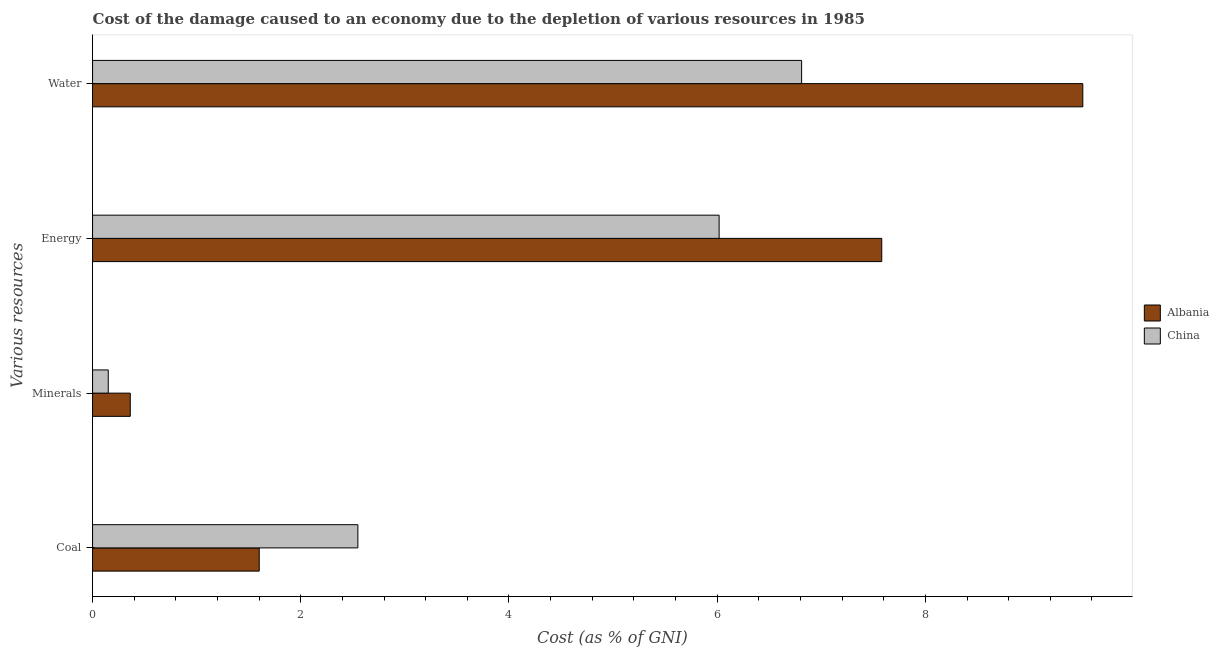How many different coloured bars are there?
Offer a terse response. 2. Are the number of bars per tick equal to the number of legend labels?
Your answer should be very brief. Yes. How many bars are there on the 4th tick from the top?
Keep it short and to the point. 2. What is the label of the 3rd group of bars from the top?
Provide a succinct answer. Minerals. What is the cost of damage due to depletion of coal in China?
Keep it short and to the point. 2.55. Across all countries, what is the maximum cost of damage due to depletion of minerals?
Your answer should be compact. 0.36. Across all countries, what is the minimum cost of damage due to depletion of coal?
Give a very brief answer. 1.6. In which country was the cost of damage due to depletion of coal minimum?
Your response must be concise. Albania. What is the total cost of damage due to depletion of coal in the graph?
Give a very brief answer. 4.15. What is the difference between the cost of damage due to depletion of water in China and that in Albania?
Ensure brevity in your answer.  -2.7. What is the difference between the cost of damage due to depletion of coal in China and the cost of damage due to depletion of minerals in Albania?
Provide a succinct answer. 2.19. What is the average cost of damage due to depletion of coal per country?
Offer a very short reply. 2.07. What is the difference between the cost of damage due to depletion of coal and cost of damage due to depletion of energy in Albania?
Keep it short and to the point. -5.98. What is the ratio of the cost of damage due to depletion of coal in Albania to that in China?
Your answer should be compact. 0.63. Is the cost of damage due to depletion of energy in China less than that in Albania?
Offer a very short reply. Yes. Is the difference between the cost of damage due to depletion of water in China and Albania greater than the difference between the cost of damage due to depletion of coal in China and Albania?
Your response must be concise. No. What is the difference between the highest and the second highest cost of damage due to depletion of water?
Offer a very short reply. 2.7. What is the difference between the highest and the lowest cost of damage due to depletion of energy?
Ensure brevity in your answer.  1.56. Is the sum of the cost of damage due to depletion of coal in Albania and China greater than the maximum cost of damage due to depletion of minerals across all countries?
Make the answer very short. Yes. What does the 2nd bar from the top in Minerals represents?
Your response must be concise. Albania. Is it the case that in every country, the sum of the cost of damage due to depletion of coal and cost of damage due to depletion of minerals is greater than the cost of damage due to depletion of energy?
Provide a succinct answer. No. What is the difference between two consecutive major ticks on the X-axis?
Provide a short and direct response. 2. Are the values on the major ticks of X-axis written in scientific E-notation?
Ensure brevity in your answer.  No. How are the legend labels stacked?
Your answer should be compact. Vertical. What is the title of the graph?
Your answer should be very brief. Cost of the damage caused to an economy due to the depletion of various resources in 1985 . Does "Monaco" appear as one of the legend labels in the graph?
Offer a very short reply. No. What is the label or title of the X-axis?
Offer a terse response. Cost (as % of GNI). What is the label or title of the Y-axis?
Keep it short and to the point. Various resources. What is the Cost (as % of GNI) in Albania in Coal?
Give a very brief answer. 1.6. What is the Cost (as % of GNI) of China in Coal?
Provide a short and direct response. 2.55. What is the Cost (as % of GNI) of Albania in Minerals?
Your answer should be very brief. 0.36. What is the Cost (as % of GNI) of China in Minerals?
Make the answer very short. 0.15. What is the Cost (as % of GNI) in Albania in Energy?
Your response must be concise. 7.58. What is the Cost (as % of GNI) of China in Energy?
Make the answer very short. 6.02. What is the Cost (as % of GNI) in Albania in Water?
Offer a terse response. 9.51. What is the Cost (as % of GNI) in China in Water?
Offer a terse response. 6.81. Across all Various resources, what is the maximum Cost (as % of GNI) of Albania?
Your answer should be compact. 9.51. Across all Various resources, what is the maximum Cost (as % of GNI) in China?
Your answer should be compact. 6.81. Across all Various resources, what is the minimum Cost (as % of GNI) in Albania?
Make the answer very short. 0.36. Across all Various resources, what is the minimum Cost (as % of GNI) in China?
Make the answer very short. 0.15. What is the total Cost (as % of GNI) of Albania in the graph?
Provide a short and direct response. 19.06. What is the total Cost (as % of GNI) in China in the graph?
Ensure brevity in your answer.  15.53. What is the difference between the Cost (as % of GNI) in Albania in Coal and that in Minerals?
Your response must be concise. 1.24. What is the difference between the Cost (as % of GNI) in China in Coal and that in Minerals?
Provide a succinct answer. 2.4. What is the difference between the Cost (as % of GNI) in Albania in Coal and that in Energy?
Your answer should be compact. -5.98. What is the difference between the Cost (as % of GNI) of China in Coal and that in Energy?
Offer a very short reply. -3.47. What is the difference between the Cost (as % of GNI) in Albania in Coal and that in Water?
Offer a terse response. -7.91. What is the difference between the Cost (as % of GNI) in China in Coal and that in Water?
Your response must be concise. -4.26. What is the difference between the Cost (as % of GNI) of Albania in Minerals and that in Energy?
Your answer should be very brief. -7.22. What is the difference between the Cost (as % of GNI) in China in Minerals and that in Energy?
Your answer should be compact. -5.87. What is the difference between the Cost (as % of GNI) of Albania in Minerals and that in Water?
Keep it short and to the point. -9.15. What is the difference between the Cost (as % of GNI) of China in Minerals and that in Water?
Your answer should be very brief. -6.66. What is the difference between the Cost (as % of GNI) of Albania in Energy and that in Water?
Give a very brief answer. -1.93. What is the difference between the Cost (as % of GNI) of China in Energy and that in Water?
Provide a short and direct response. -0.79. What is the difference between the Cost (as % of GNI) in Albania in Coal and the Cost (as % of GNI) in China in Minerals?
Make the answer very short. 1.45. What is the difference between the Cost (as % of GNI) of Albania in Coal and the Cost (as % of GNI) of China in Energy?
Your response must be concise. -4.42. What is the difference between the Cost (as % of GNI) in Albania in Coal and the Cost (as % of GNI) in China in Water?
Your answer should be very brief. -5.21. What is the difference between the Cost (as % of GNI) of Albania in Minerals and the Cost (as % of GNI) of China in Energy?
Ensure brevity in your answer.  -5.66. What is the difference between the Cost (as % of GNI) of Albania in Minerals and the Cost (as % of GNI) of China in Water?
Offer a terse response. -6.45. What is the difference between the Cost (as % of GNI) of Albania in Energy and the Cost (as % of GNI) of China in Water?
Provide a short and direct response. 0.77. What is the average Cost (as % of GNI) of Albania per Various resources?
Make the answer very short. 4.76. What is the average Cost (as % of GNI) of China per Various resources?
Your response must be concise. 3.88. What is the difference between the Cost (as % of GNI) of Albania and Cost (as % of GNI) of China in Coal?
Your answer should be very brief. -0.95. What is the difference between the Cost (as % of GNI) in Albania and Cost (as % of GNI) in China in Minerals?
Provide a short and direct response. 0.21. What is the difference between the Cost (as % of GNI) in Albania and Cost (as % of GNI) in China in Energy?
Offer a very short reply. 1.56. What is the difference between the Cost (as % of GNI) in Albania and Cost (as % of GNI) in China in Water?
Make the answer very short. 2.7. What is the ratio of the Cost (as % of GNI) of Albania in Coal to that in Minerals?
Give a very brief answer. 4.42. What is the ratio of the Cost (as % of GNI) in China in Coal to that in Minerals?
Keep it short and to the point. 16.91. What is the ratio of the Cost (as % of GNI) of Albania in Coal to that in Energy?
Give a very brief answer. 0.21. What is the ratio of the Cost (as % of GNI) of China in Coal to that in Energy?
Keep it short and to the point. 0.42. What is the ratio of the Cost (as % of GNI) of Albania in Coal to that in Water?
Ensure brevity in your answer.  0.17. What is the ratio of the Cost (as % of GNI) in China in Coal to that in Water?
Give a very brief answer. 0.37. What is the ratio of the Cost (as % of GNI) in Albania in Minerals to that in Energy?
Keep it short and to the point. 0.05. What is the ratio of the Cost (as % of GNI) in China in Minerals to that in Energy?
Your answer should be very brief. 0.03. What is the ratio of the Cost (as % of GNI) of Albania in Minerals to that in Water?
Make the answer very short. 0.04. What is the ratio of the Cost (as % of GNI) in China in Minerals to that in Water?
Your response must be concise. 0.02. What is the ratio of the Cost (as % of GNI) in Albania in Energy to that in Water?
Make the answer very short. 0.8. What is the ratio of the Cost (as % of GNI) in China in Energy to that in Water?
Provide a succinct answer. 0.88. What is the difference between the highest and the second highest Cost (as % of GNI) in Albania?
Offer a very short reply. 1.93. What is the difference between the highest and the second highest Cost (as % of GNI) of China?
Offer a terse response. 0.79. What is the difference between the highest and the lowest Cost (as % of GNI) in Albania?
Provide a short and direct response. 9.15. What is the difference between the highest and the lowest Cost (as % of GNI) of China?
Keep it short and to the point. 6.66. 